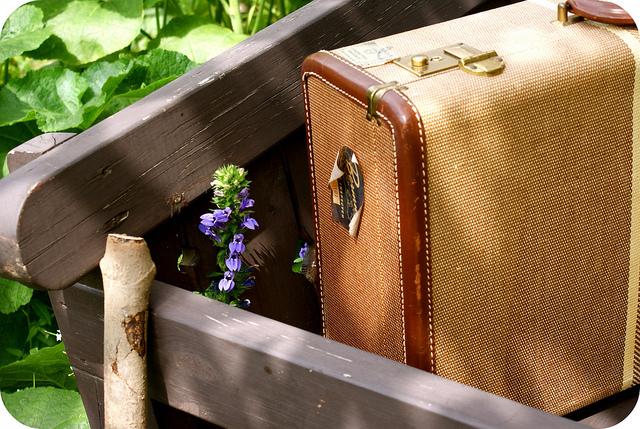Is the suitcase in the middle of a flower bed?
Write a very short answer. Yes. What color is the suitcase?
Quick response, please. Brown. What is peeling off of the suitcase?
Give a very brief answer. Sticker. 